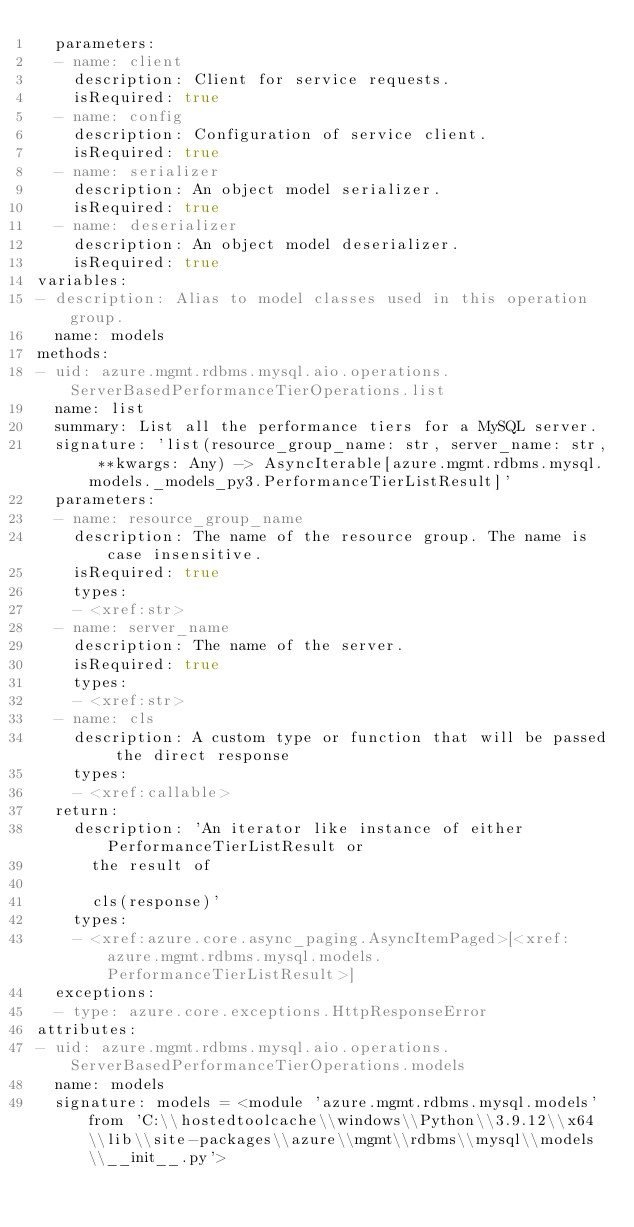Convert code to text. <code><loc_0><loc_0><loc_500><loc_500><_YAML_>  parameters:
  - name: client
    description: Client for service requests.
    isRequired: true
  - name: config
    description: Configuration of service client.
    isRequired: true
  - name: serializer
    description: An object model serializer.
    isRequired: true
  - name: deserializer
    description: An object model deserializer.
    isRequired: true
variables:
- description: Alias to model classes used in this operation group.
  name: models
methods:
- uid: azure.mgmt.rdbms.mysql.aio.operations.ServerBasedPerformanceTierOperations.list
  name: list
  summary: List all the performance tiers for a MySQL server.
  signature: 'list(resource_group_name: str, server_name: str, **kwargs: Any) -> AsyncIterable[azure.mgmt.rdbms.mysql.models._models_py3.PerformanceTierListResult]'
  parameters:
  - name: resource_group_name
    description: The name of the resource group. The name is case insensitive.
    isRequired: true
    types:
    - <xref:str>
  - name: server_name
    description: The name of the server.
    isRequired: true
    types:
    - <xref:str>
  - name: cls
    description: A custom type or function that will be passed the direct response
    types:
    - <xref:callable>
  return:
    description: 'An iterator like instance of either PerformanceTierListResult or
      the result of

      cls(response)'
    types:
    - <xref:azure.core.async_paging.AsyncItemPaged>[<xref:azure.mgmt.rdbms.mysql.models.PerformanceTierListResult>]
  exceptions:
  - type: azure.core.exceptions.HttpResponseError
attributes:
- uid: azure.mgmt.rdbms.mysql.aio.operations.ServerBasedPerformanceTierOperations.models
  name: models
  signature: models = <module 'azure.mgmt.rdbms.mysql.models' from 'C:\\hostedtoolcache\\windows\\Python\\3.9.12\\x64\\lib\\site-packages\\azure\\mgmt\\rdbms\\mysql\\models\\__init__.py'>
</code> 